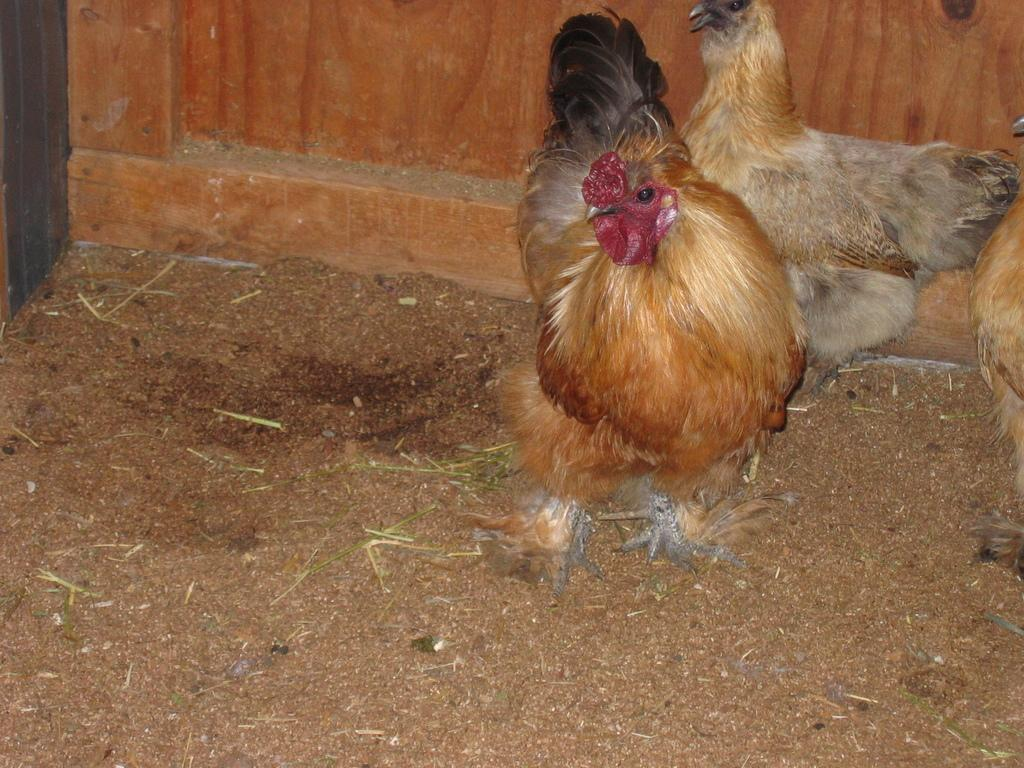What animals are present in the image? There are cocks in the image. Where are the cocks located in the image? The cocks are on the right side of the image. What is the condition of the area where the cocks are located? The cocks are in a muddy area. What type of muscle is being used by the cocks in the image? There is no indication in the image of which muscles the cocks are using, as they are not performing any actions that would require specific muscle groups. 